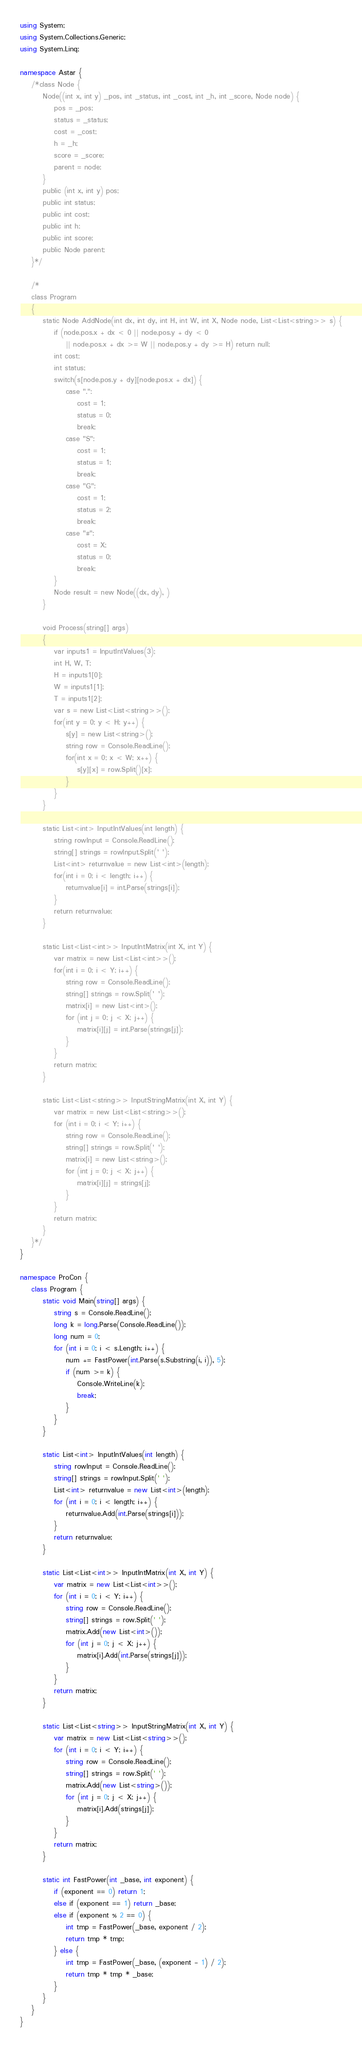Convert code to text. <code><loc_0><loc_0><loc_500><loc_500><_C#_>using System;
using System.Collections.Generic;
using System.Linq;

namespace Astar {
    /*class Node {
        Node((int x, int y) _pos, int _status, int _cost, int _h, int _score, Node node) {
            pos = _pos;
            status = _status;
            cost = _cost;
            h = _h;
            score = _score;
            parent = node;
        }
        public (int x, int y) pos;
        public int status;
        public int cost;
        public int h;
        public int score;
        public Node parent;
    }*/

    /*
    class Program
    {
        static Node AddNode(int dx, int dy, int H, int W, int X, Node node, List<List<string>> s) {
            if (node.pos.x + dx < 0 || node.pos.y + dy < 0
                || node.pos.x + dx >= W || node.pos.y + dy >= H) return null;
            int cost;
            int status;
            switch(s[node.pos.y + dy][node.pos.x + dx]) {
                case ".":
                    cost = 1;
                    status = 0;
                    break;
                case "S":
                    cost = 1;
                    status = 1;
                    break;
                case "G":
                    cost = 1;
                    status = 2;
                    break;
                case "#":
                    cost = X;
                    status = 0;
                    break;
            }
            Node result = new Node((dx, dy), )
        }

        void Process(string[] args)
        {
            var inputs1 = InputIntValues(3);
            int H, W, T;
            H = inputs1[0];
            W = inputs1[1];
            T = inputs1[2];
            var s = new List<List<string>>();
            for(int y = 0; y < H; y++) {
                s[y] = new List<string>();
                string row = Console.ReadLine();
                for(int x = 0; x < W; x++) {
                    s[y][x] = row.Split()[x];
                }
            }
        }

        static List<int> InputIntValues(int length) {
            string rowInput = Console.ReadLine();
            string[] strings = rowInput.Split(' ');
            List<int> returnvalue = new List<int>(length);
            for(int i = 0; i < length; i++) {
                returnvalue[i] = int.Parse(strings[i]);
            }
            return returnvalue;
        }

        static List<List<int>> InputIntMatrix(int X, int Y) {
            var matrix = new List<List<int>>();
            for(int i = 0; i < Y; i++) {
                string row = Console.ReadLine();
                string[] strings = row.Split(' ');
                matrix[i] = new List<int>();
                for (int j = 0; j < X; j++) {
                    matrix[i][j] = int.Parse(strings[j]);
                }
            }
            return matrix;
        }

        static List<List<string>> InputStringMatrix(int X, int Y) {
            var matrix = new List<List<string>>();
            for (int i = 0; i < Y; i++) {
                string row = Console.ReadLine();
                string[] strings = row.Split(' ');
                matrix[i] = new List<string>();
                for (int j = 0; j < X; j++) {
                    matrix[i][j] = strings[j];
                }
            }
            return matrix;
        }
    }*/
}

namespace ProCon {
    class Program {
        static void Main(string[] args) {
            string s = Console.ReadLine();
            long k = long.Parse(Console.ReadLine());
            long num = 0;
            for (int i = 0; i < s.Length; i++) {
                num += FastPower(int.Parse(s.Substring(i, i)), 5);
                if (num >= k) {
                    Console.WriteLine(k);
                    break;
                }
            }
        }

        static List<int> InputIntValues(int length) {
            string rowInput = Console.ReadLine();
            string[] strings = rowInput.Split(' ');
            List<int> returnvalue = new List<int>(length);
            for (int i = 0; i < length; i++) {
                returnvalue.Add(int.Parse(strings[i]));
            }
            return returnvalue;
        }

        static List<List<int>> InputIntMatrix(int X, int Y) {
            var matrix = new List<List<int>>();
            for (int i = 0; i < Y; i++) {
                string row = Console.ReadLine();
                string[] strings = row.Split(' ');
                matrix.Add(new List<int>());
                for (int j = 0; j < X; j++) {
                    matrix[i].Add(int.Parse(strings[j]));
                }
            }
            return matrix;
        }

        static List<List<string>> InputStringMatrix(int X, int Y) {
            var matrix = new List<List<string>>();
            for (int i = 0; i < Y; i++) {
                string row = Console.ReadLine();
                string[] strings = row.Split(' ');
                matrix.Add(new List<string>());
                for (int j = 0; j < X; j++) {
                    matrix[i].Add(strings[j]);
                }
            }
            return matrix;
        }

        static int FastPower(int _base, int exponent) {
            if (exponent == 0) return 1;
            else if (exponent == 1) return _base;
            else if (exponent % 2 == 0) {
                int tmp = FastPower(_base, exponent / 2);
                return tmp * tmp;
            } else {
                int tmp = FastPower(_base, (exponent - 1) / 2);
                return tmp * tmp * _base;
            }
        }
    }
}
</code> 